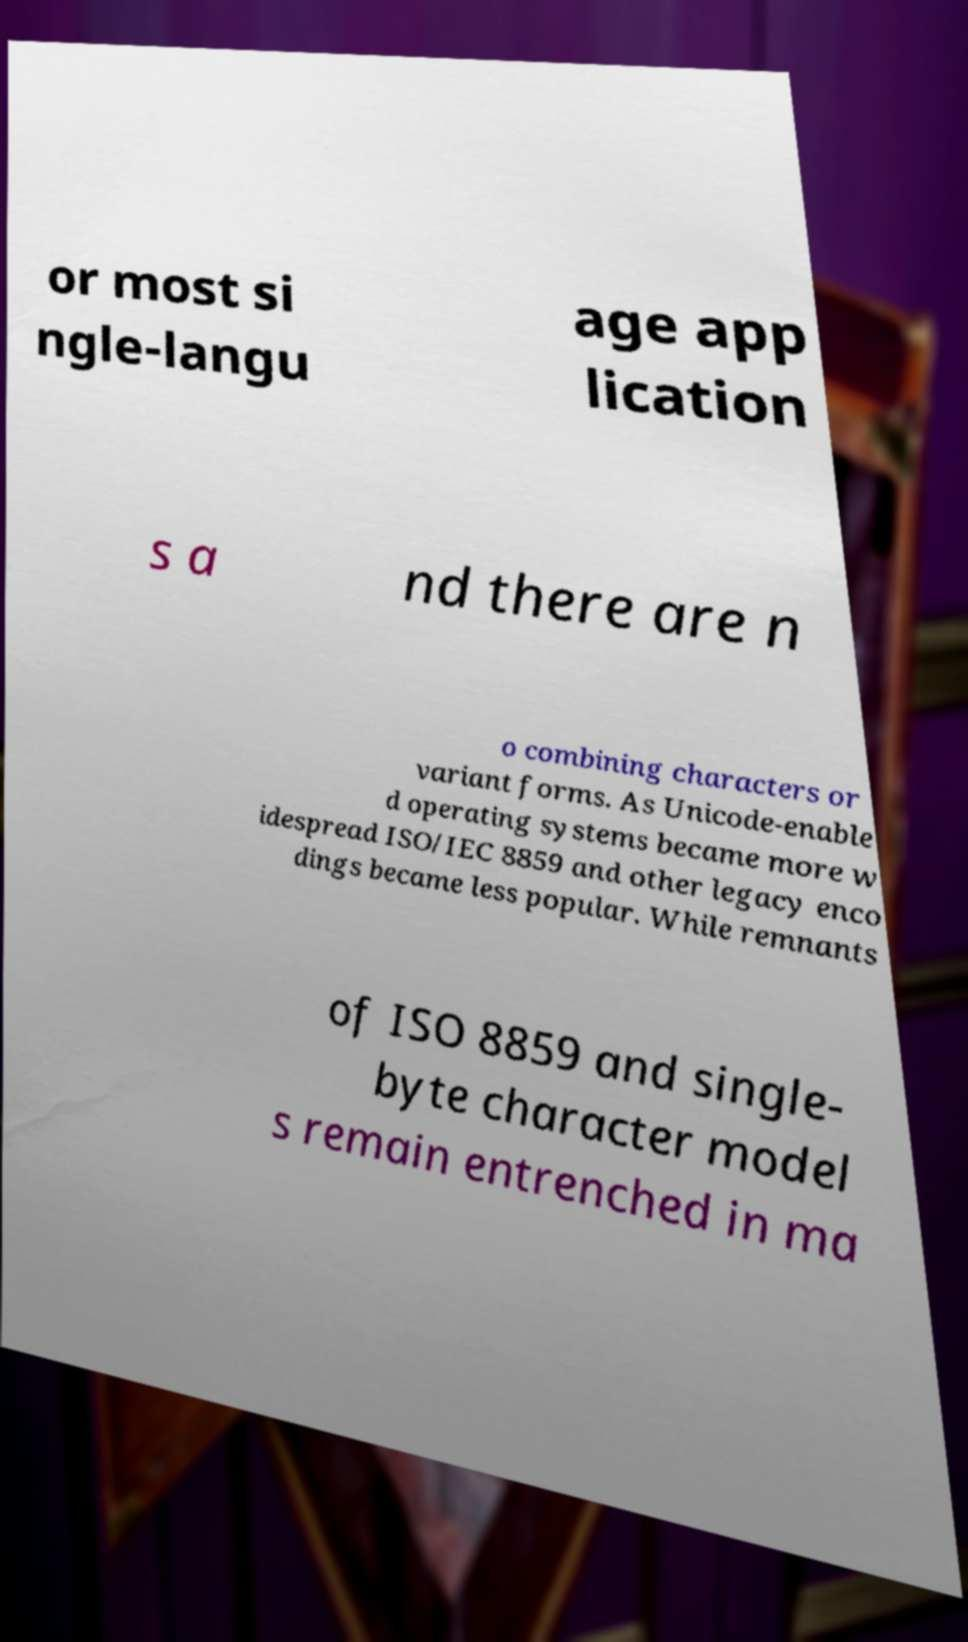Can you accurately transcribe the text from the provided image for me? or most si ngle-langu age app lication s a nd there are n o combining characters or variant forms. As Unicode-enable d operating systems became more w idespread ISO/IEC 8859 and other legacy enco dings became less popular. While remnants of ISO 8859 and single- byte character model s remain entrenched in ma 